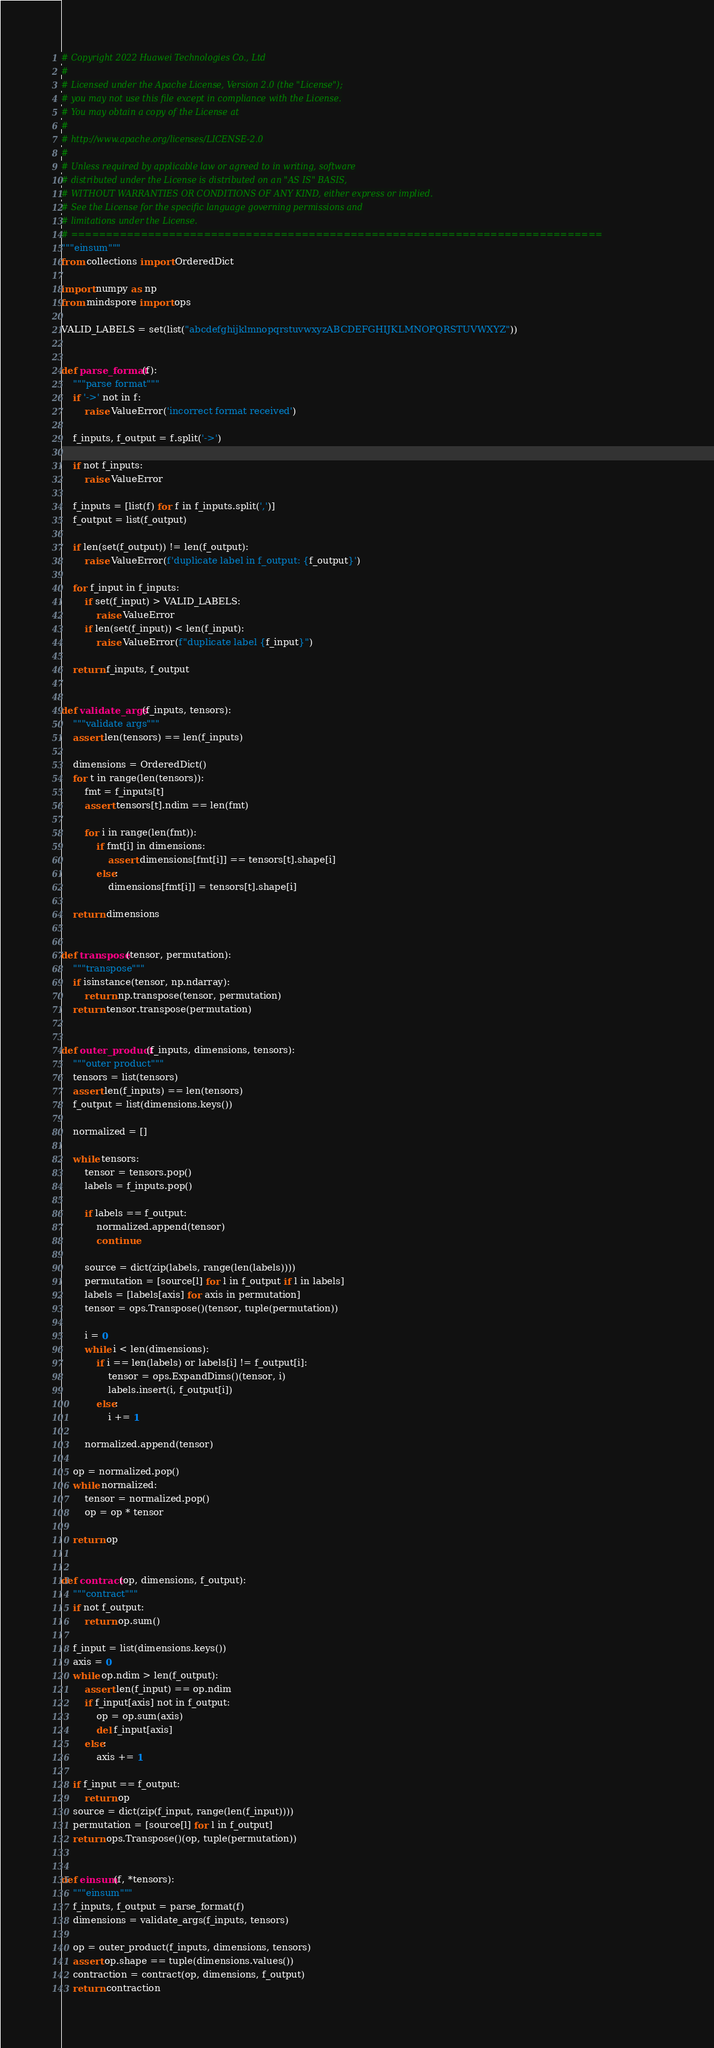<code> <loc_0><loc_0><loc_500><loc_500><_Python_># Copyright 2022 Huawei Technologies Co., Ltd
#
# Licensed under the Apache License, Version 2.0 (the "License");
# you may not use this file except in compliance with the License.
# You may obtain a copy of the License at
#
# http://www.apache.org/licenses/LICENSE-2.0
#
# Unless required by applicable law or agreed to in writing, software
# distributed under the License is distributed on an "AS IS" BASIS,
# WITHOUT WARRANTIES OR CONDITIONS OF ANY KIND, either express or implied.
# See the License for the specific language governing permissions and
# limitations under the License.
# ============================================================================
"""einsum"""
from collections import OrderedDict

import numpy as np
from mindspore import ops

VALID_LABELS = set(list("abcdefghijklmnopqrstuvwxyzABCDEFGHIJKLMNOPQRSTUVWXYZ"))


def parse_format(f):
    """parse format"""
    if '->' not in f:
        raise ValueError('incorrect format received')

    f_inputs, f_output = f.split('->')

    if not f_inputs:
        raise ValueError

    f_inputs = [list(f) for f in f_inputs.split(',')]
    f_output = list(f_output)

    if len(set(f_output)) != len(f_output):
        raise ValueError(f'duplicate label in f_output: {f_output}')

    for f_input in f_inputs:
        if set(f_input) > VALID_LABELS:
            raise ValueError
        if len(set(f_input)) < len(f_input):
            raise ValueError(f"duplicate label {f_input}")

    return f_inputs, f_output


def validate_args(f_inputs, tensors):
    """validate args"""
    assert len(tensors) == len(f_inputs)

    dimensions = OrderedDict()
    for t in range(len(tensors)):
        fmt = f_inputs[t]
        assert tensors[t].ndim == len(fmt)

        for i in range(len(fmt)):
            if fmt[i] in dimensions:
                assert dimensions[fmt[i]] == tensors[t].shape[i]
            else:
                dimensions[fmt[i]] = tensors[t].shape[i]

    return dimensions


def transpose(tensor, permutation):
    """transpose"""
    if isinstance(tensor, np.ndarray):
        return np.transpose(tensor, permutation)
    return tensor.transpose(permutation)


def outer_product(f_inputs, dimensions, tensors):
    """outer product"""
    tensors = list(tensors)
    assert len(f_inputs) == len(tensors)
    f_output = list(dimensions.keys())

    normalized = []

    while tensors:
        tensor = tensors.pop()
        labels = f_inputs.pop()

        if labels == f_output:
            normalized.append(tensor)
            continue

        source = dict(zip(labels, range(len(labels))))
        permutation = [source[l] for l in f_output if l in labels]
        labels = [labels[axis] for axis in permutation]
        tensor = ops.Transpose()(tensor, tuple(permutation))

        i = 0
        while i < len(dimensions):
            if i == len(labels) or labels[i] != f_output[i]:
                tensor = ops.ExpandDims()(tensor, i)
                labels.insert(i, f_output[i])
            else:
                i += 1

        normalized.append(tensor)

    op = normalized.pop()
    while normalized:
        tensor = normalized.pop()
        op = op * tensor

    return op


def contract(op, dimensions, f_output):
    """contract"""
    if not f_output:
        return op.sum()

    f_input = list(dimensions.keys())
    axis = 0
    while op.ndim > len(f_output):
        assert len(f_input) == op.ndim
        if f_input[axis] not in f_output:
            op = op.sum(axis)
            del f_input[axis]
        else:
            axis += 1

    if f_input == f_output:
        return op
    source = dict(zip(f_input, range(len(f_input))))
    permutation = [source[l] for l in f_output]
    return ops.Transpose()(op, tuple(permutation))


def einsum(f, *tensors):
    """einsum"""
    f_inputs, f_output = parse_format(f)
    dimensions = validate_args(f_inputs, tensors)

    op = outer_product(f_inputs, dimensions, tensors)
    assert op.shape == tuple(dimensions.values())
    contraction = contract(op, dimensions, f_output)
    return contraction
</code> 